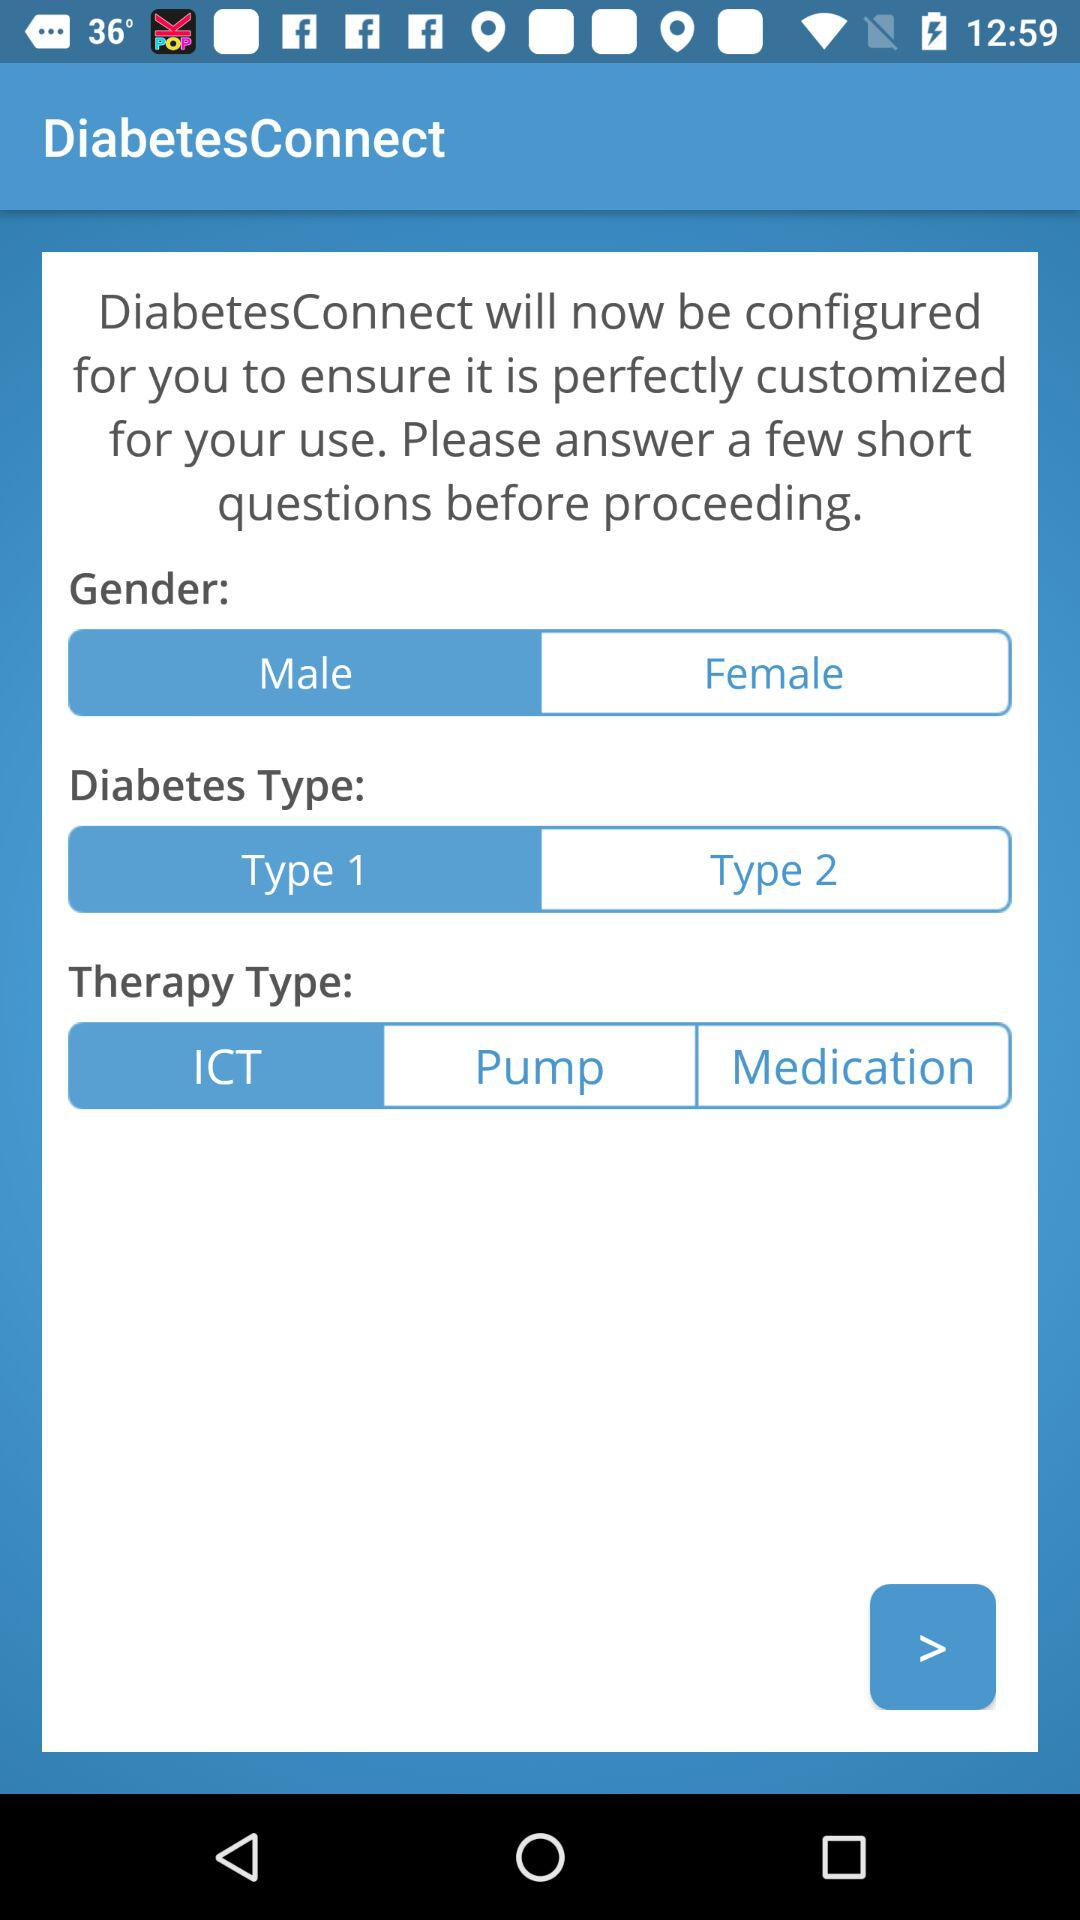What's the gender of the person? The gender of the person is male. 